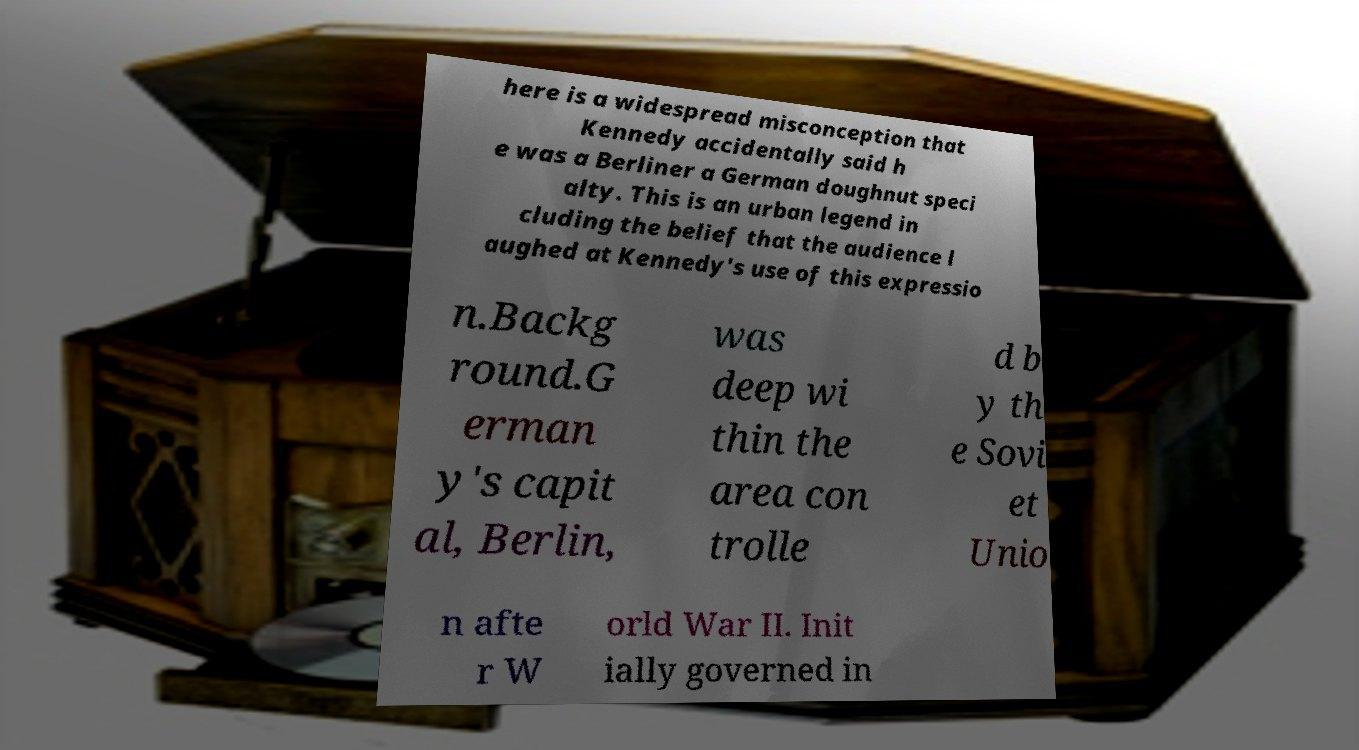What messages or text are displayed in this image? I need them in a readable, typed format. here is a widespread misconception that Kennedy accidentally said h e was a Berliner a German doughnut speci alty. This is an urban legend in cluding the belief that the audience l aughed at Kennedy's use of this expressio n.Backg round.G erman y's capit al, Berlin, was deep wi thin the area con trolle d b y th e Sovi et Unio n afte r W orld War II. Init ially governed in 